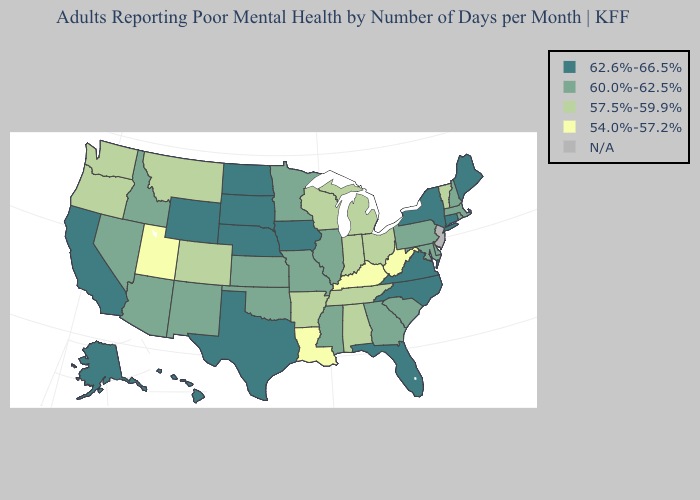What is the value of Oklahoma?
Write a very short answer. 60.0%-62.5%. Which states have the highest value in the USA?
Answer briefly. Alaska, California, Connecticut, Florida, Hawaii, Iowa, Maine, Nebraska, New York, North Carolina, North Dakota, South Dakota, Texas, Virginia, Wyoming. What is the lowest value in the USA?
Keep it brief. 54.0%-57.2%. Does Nebraska have the highest value in the USA?
Answer briefly. Yes. Name the states that have a value in the range N/A?
Answer briefly. New Jersey. Which states have the lowest value in the South?
Keep it brief. Kentucky, Louisiana, West Virginia. Name the states that have a value in the range 62.6%-66.5%?
Be succinct. Alaska, California, Connecticut, Florida, Hawaii, Iowa, Maine, Nebraska, New York, North Carolina, North Dakota, South Dakota, Texas, Virginia, Wyoming. What is the lowest value in the South?
Concise answer only. 54.0%-57.2%. What is the value of Delaware?
Be succinct. 60.0%-62.5%. Among the states that border Wyoming , which have the highest value?
Write a very short answer. Nebraska, South Dakota. Which states have the lowest value in the West?
Concise answer only. Utah. Does Kentucky have the lowest value in the USA?
Keep it brief. Yes. Among the states that border Florida , which have the lowest value?
Answer briefly. Alabama. What is the lowest value in states that border Nebraska?
Answer briefly. 57.5%-59.9%. Which states have the highest value in the USA?
Keep it brief. Alaska, California, Connecticut, Florida, Hawaii, Iowa, Maine, Nebraska, New York, North Carolina, North Dakota, South Dakota, Texas, Virginia, Wyoming. 